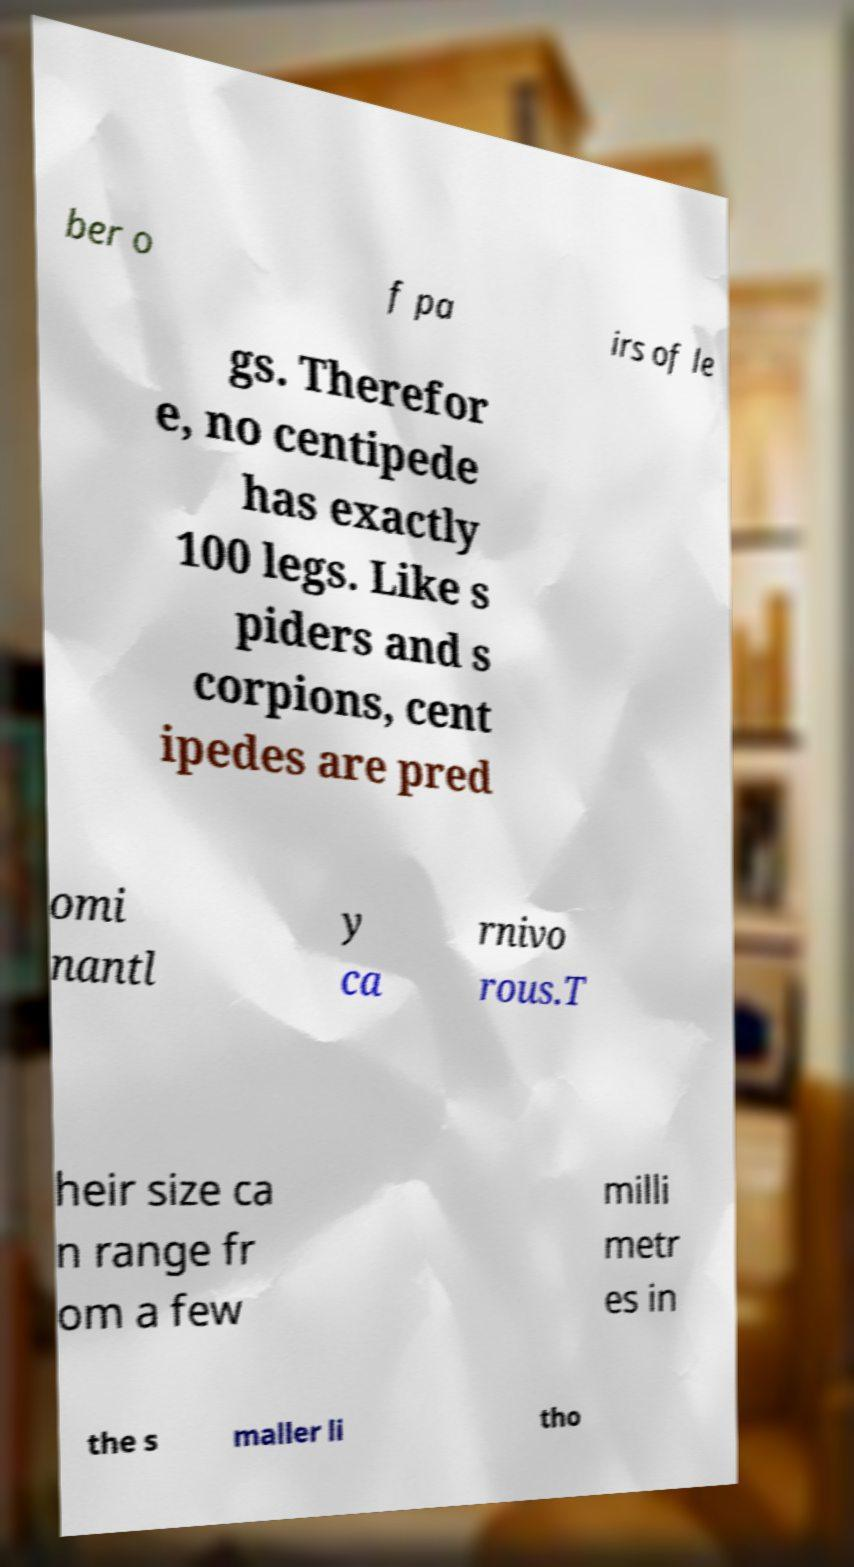Could you extract and type out the text from this image? ber o f pa irs of le gs. Therefor e, no centipede has exactly 100 legs. Like s piders and s corpions, cent ipedes are pred omi nantl y ca rnivo rous.T heir size ca n range fr om a few milli metr es in the s maller li tho 